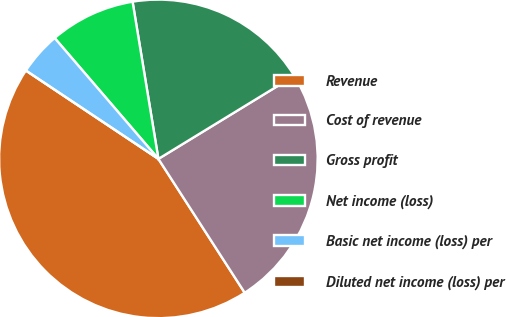Convert chart. <chart><loc_0><loc_0><loc_500><loc_500><pie_chart><fcel>Revenue<fcel>Cost of revenue<fcel>Gross profit<fcel>Net income (loss)<fcel>Basic net income (loss) per<fcel>Diluted net income (loss) per<nl><fcel>43.48%<fcel>24.62%<fcel>18.86%<fcel>8.7%<fcel>4.35%<fcel>0.0%<nl></chart> 